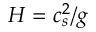Convert formula to latex. <formula><loc_0><loc_0><loc_500><loc_500>H = c _ { s } ^ { 2 } / g</formula> 